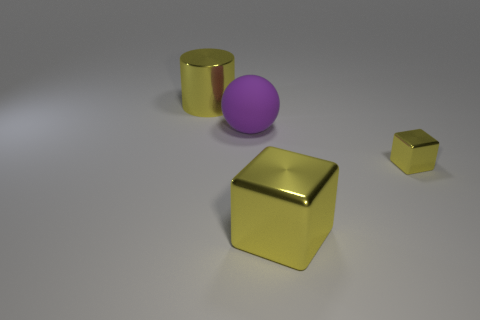Are any big blocks visible?
Offer a very short reply. Yes. There is a big shiny object behind the small yellow thing; what is its color?
Your response must be concise. Yellow. There is a small object that is the same color as the big block; what is its material?
Provide a succinct answer. Metal. Are there any small cubes behind the big sphere?
Provide a succinct answer. No. Is the number of large matte balls greater than the number of small gray matte cylinders?
Offer a terse response. Yes. What color is the large rubber object to the left of the big yellow shiny thing right of the large thing that is behind the big rubber thing?
Provide a short and direct response. Purple. The other block that is the same material as the big yellow block is what color?
Keep it short and to the point. Yellow. Is there anything else that is the same size as the cylinder?
Give a very brief answer. Yes. What number of things are either big things on the right side of the big metal cylinder or yellow shiny objects that are on the right side of the cylinder?
Offer a very short reply. 3. Does the cube that is to the left of the tiny yellow object have the same size as the yellow object behind the large purple thing?
Provide a short and direct response. Yes. 